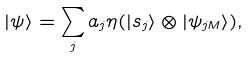Convert formula to latex. <formula><loc_0><loc_0><loc_500><loc_500>| \psi \rangle = \sum _ { j } a _ { j } \eta ( | s _ { j } \rangle \otimes | \psi _ { j M } \rangle ) ,</formula> 